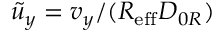<formula> <loc_0><loc_0><loc_500><loc_500>\tilde { u } _ { y } = v _ { y } / ( { R _ { e f f } D _ { 0 R } } )</formula> 